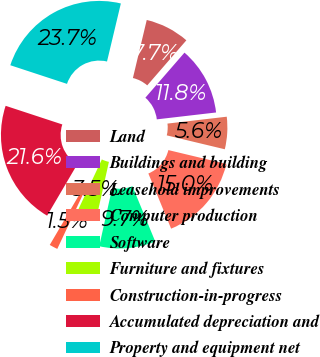<chart> <loc_0><loc_0><loc_500><loc_500><pie_chart><fcel>Land<fcel>Buildings and building<fcel>Leasehold improvements<fcel>Computer production<fcel>Software<fcel>Furniture and fixtures<fcel>Construction-in-progress<fcel>Accumulated depreciation and<fcel>Property and equipment net<nl><fcel>7.65%<fcel>11.78%<fcel>5.58%<fcel>15.03%<fcel>9.71%<fcel>3.52%<fcel>1.45%<fcel>21.6%<fcel>23.67%<nl></chart> 